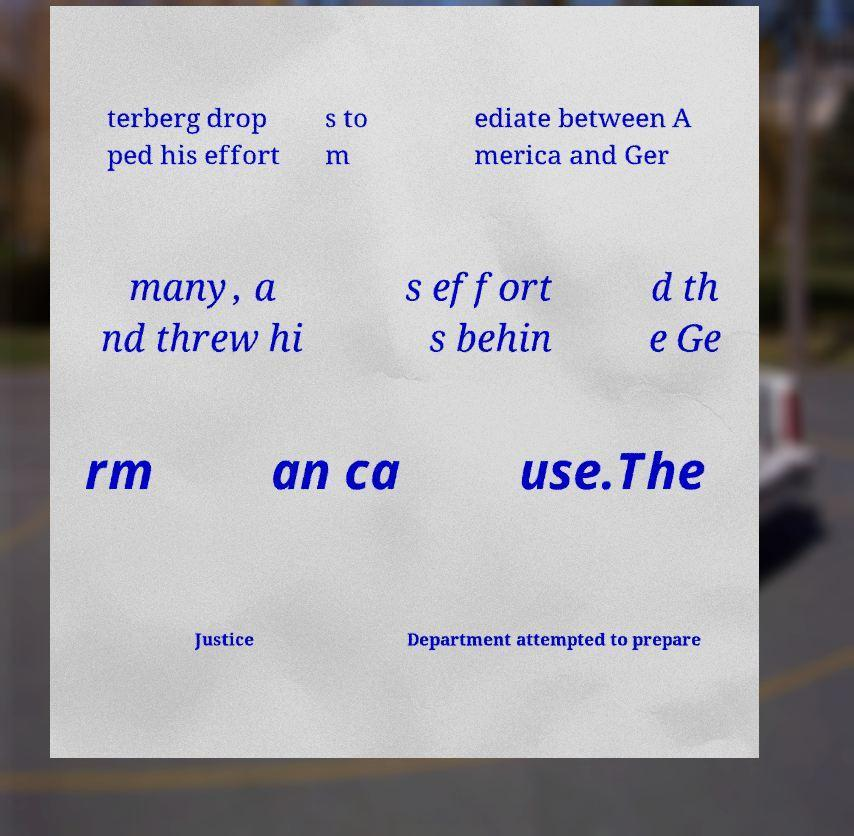There's text embedded in this image that I need extracted. Can you transcribe it verbatim? terberg drop ped his effort s to m ediate between A merica and Ger many, a nd threw hi s effort s behin d th e Ge rm an ca use.The Justice Department attempted to prepare 